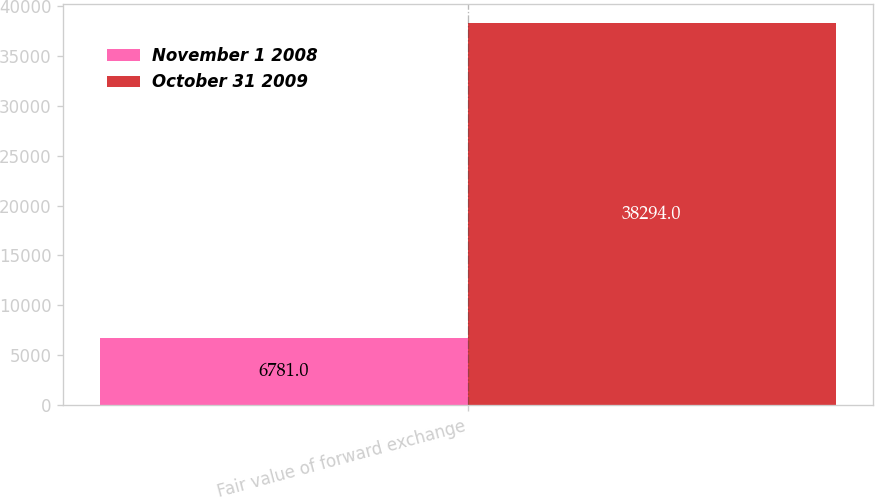Convert chart to OTSL. <chart><loc_0><loc_0><loc_500><loc_500><stacked_bar_chart><ecel><fcel>Fair value of forward exchange<nl><fcel>November 1 2008<fcel>6781<nl><fcel>October 31 2009<fcel>38294<nl></chart> 